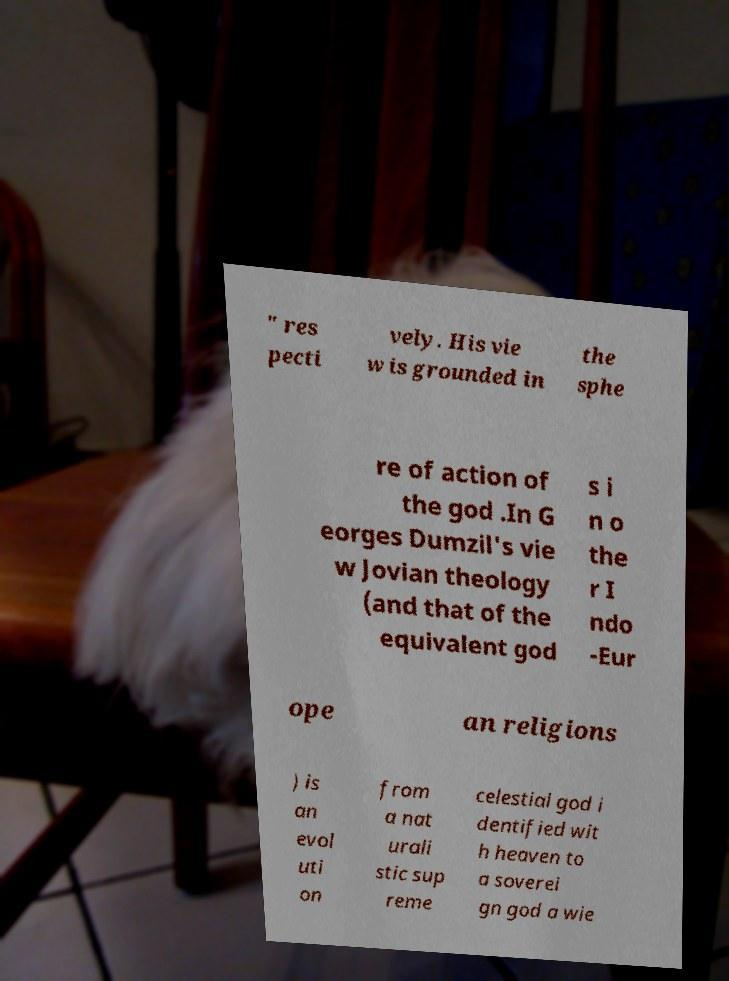Please identify and transcribe the text found in this image. " res pecti vely. His vie w is grounded in the sphe re of action of the god .In G eorges Dumzil's vie w Jovian theology (and that of the equivalent god s i n o the r I ndo -Eur ope an religions ) is an evol uti on from a nat urali stic sup reme celestial god i dentified wit h heaven to a soverei gn god a wie 